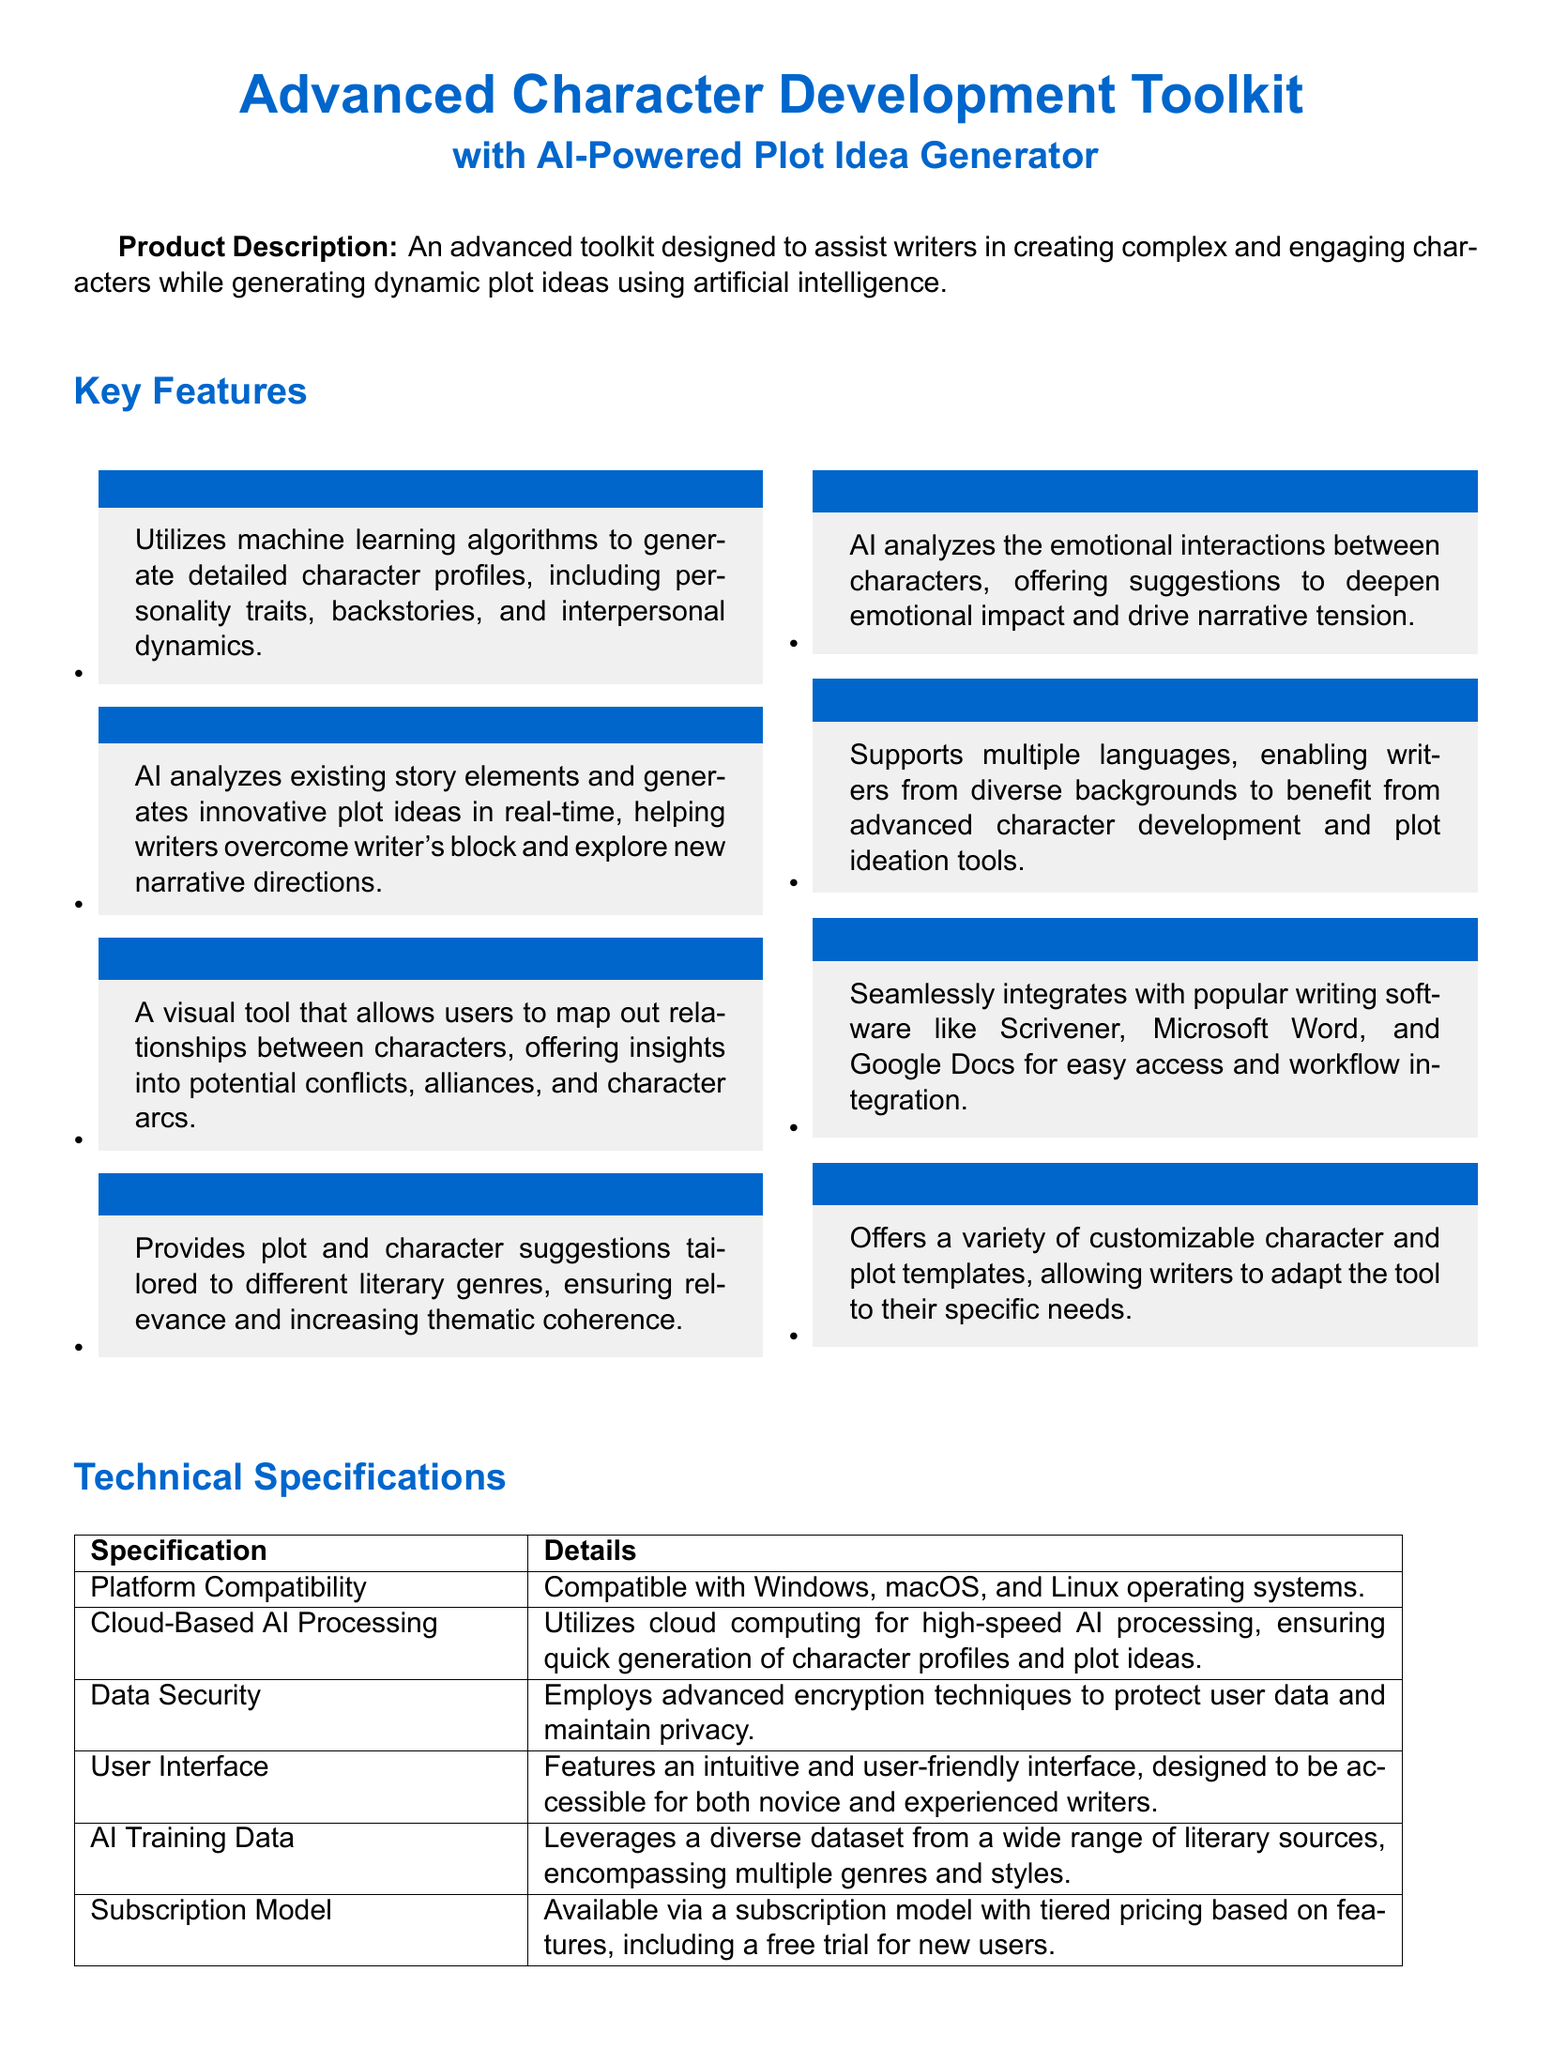What is the main purpose of the toolkit? The main purpose is to assist writers in creating complex and engaging characters while generating dynamic plot ideas.
Answer: Assist writers in character creation and plot generation How many key features are listed in the document? The number of features is found by counting the items in the Key Features section, which contains eight features.
Answer: Eight What is one benefit of the Interactive Character Relationships Map? The benefit relates to the insights it provides into potential conflicts, alliances, and character arcs.
Answer: Offers insights into conflicts and alliances What platforms is the toolkit compatible with? The platforms are explicitly mentioned as being compatible with Windows, macOS, and Linux operating systems.
Answer: Windows, macOS, Linux What type of user interface does the toolkit have? The user interface is described as intuitive and user-friendly, catering to various skill levels.
Answer: Intuitive and user-friendly How does the toolkit ensure user data security? Data security measures include the use of advanced encryption techniques.
Answer: Advanced encryption techniques What is the subscription model for the toolkit? The subscription model includes tiered pricing and offers a free trial for new users.
Answer: Tiered pricing with a free trial Which feature helps overcome writer's block? The feature that assists with this is Real-Time Plot Idea Generation.
Answer: Real-Time Plot Idea Generation 